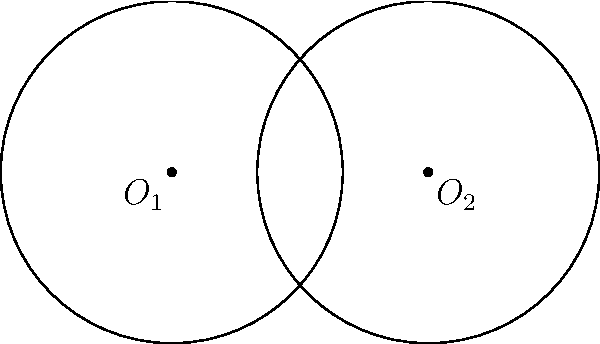As a member of the Change Creator team, you're working on a project involving overlapping circular fields. Two circular fields with radius 2 units have their centers 3 units apart. Calculate the area of the overlapping region between these two fields. Round your answer to two decimal places. Let's approach this step-by-step:

1) First, we need to find the area of the sector in one circle:
   Angle of the sector: $\theta = 2 \arccos(\frac{3}{4}) = 2.0944$ radians
   Area of sector: $A_{sector} = \frac{1}{2} r^2 \theta = \frac{1}{2} \cdot 2^2 \cdot 2.0944 = 4.1888$ sq units

2) Now, we need to find the area of the triangle formed by the two circle centers and one of the intersection points:
   Base of the triangle = 3 units
   Height of the triangle = $\sqrt{2^2 - (\frac{3}{2})^2} = \sqrt{4 - 2.25} = \sqrt{1.75} = 1.3229$ units
   Area of triangle = $\frac{1}{2} \cdot 3 \cdot 1.3229 = 1.9843$ sq units

3) The area of the overlap is twice the difference between the sector area and the triangle area:
   $A_{overlap} = 2(A_{sector} - A_{triangle}) = 2(4.1888 - 1.9843) = 4.4090$ sq units

4) Rounding to two decimal places: 4.41 sq units
Answer: 4.41 sq units 